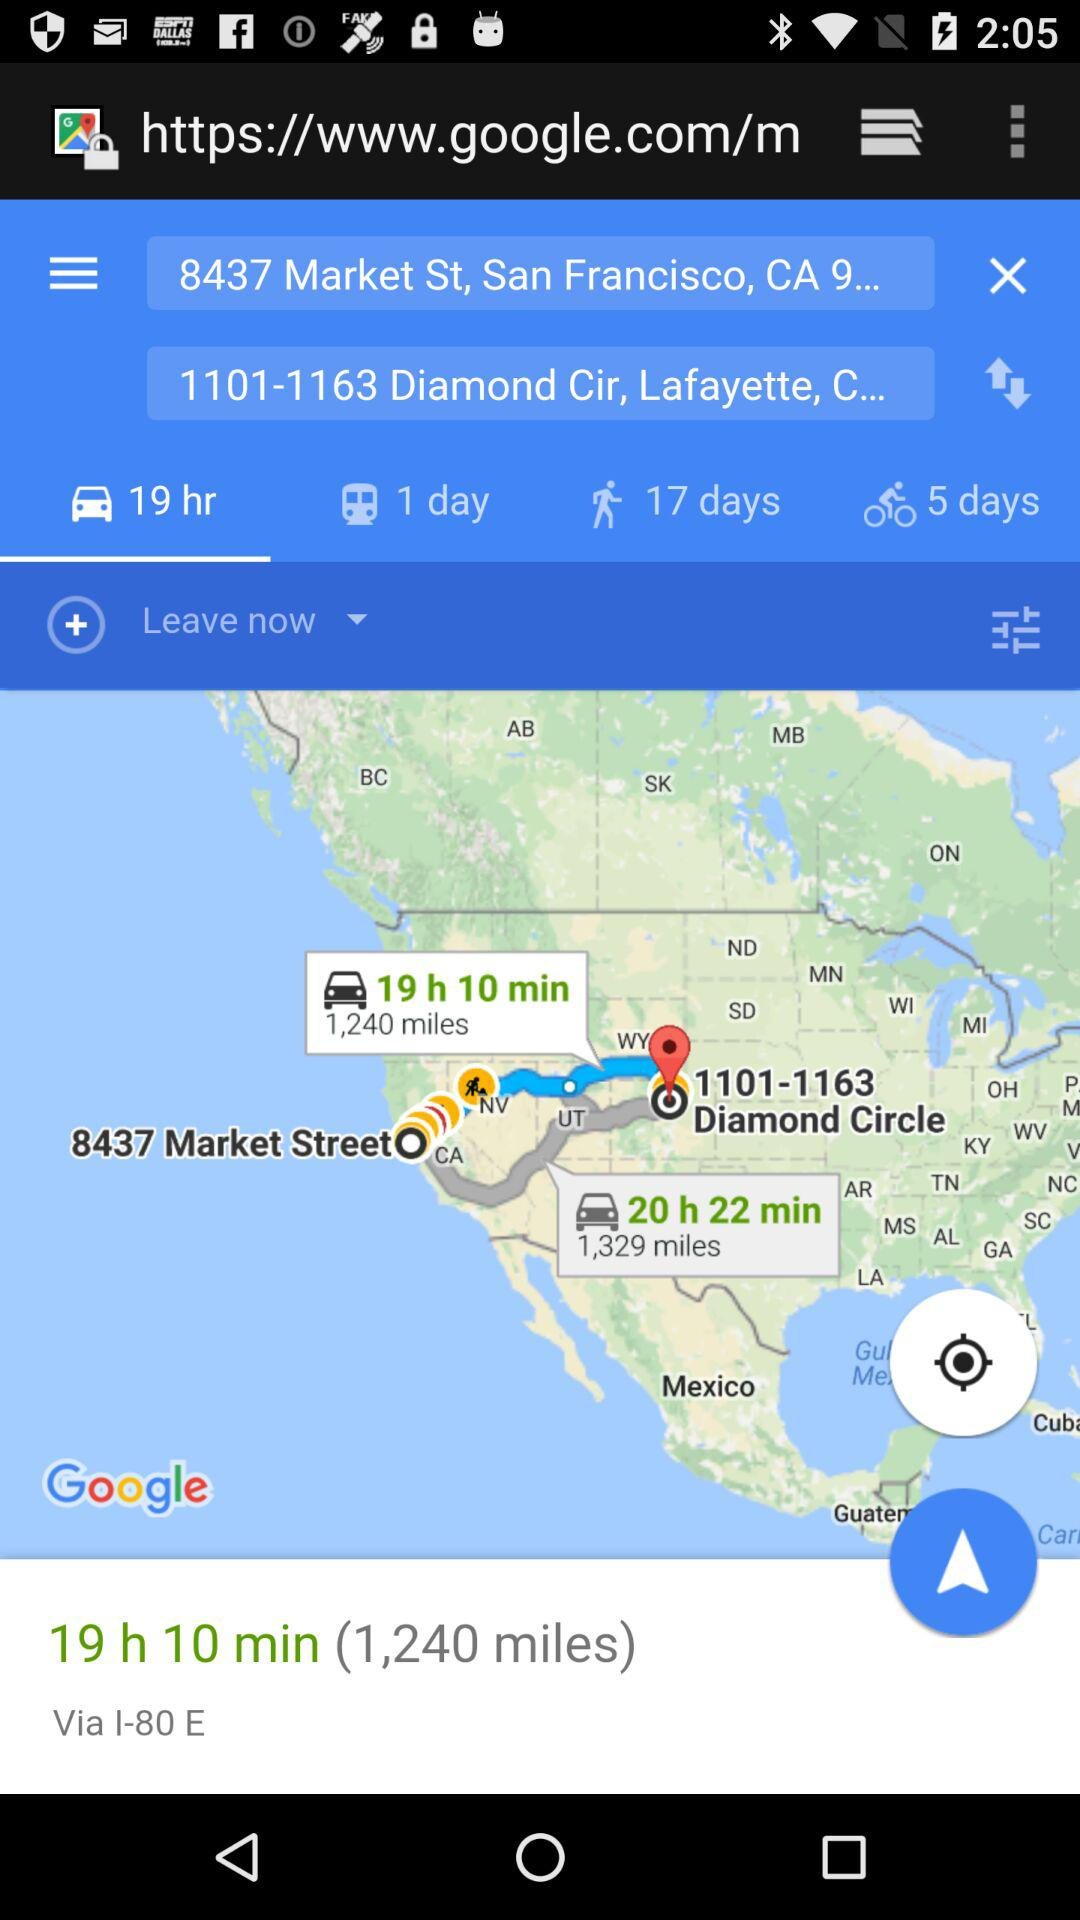What is the start location given on the screen? The given start location is "8437 Market St, San Francisco, CA 9...". 